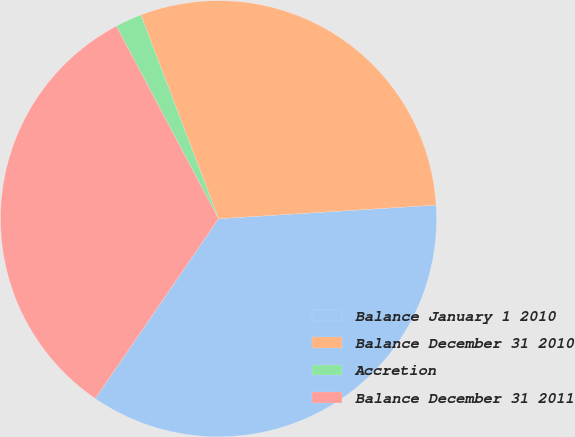Convert chart. <chart><loc_0><loc_0><loc_500><loc_500><pie_chart><fcel>Balance January 1 2010<fcel>Balance December 31 2010<fcel>Accretion<fcel>Balance December 31 2011<nl><fcel>35.56%<fcel>29.8%<fcel>1.97%<fcel>32.68%<nl></chart> 